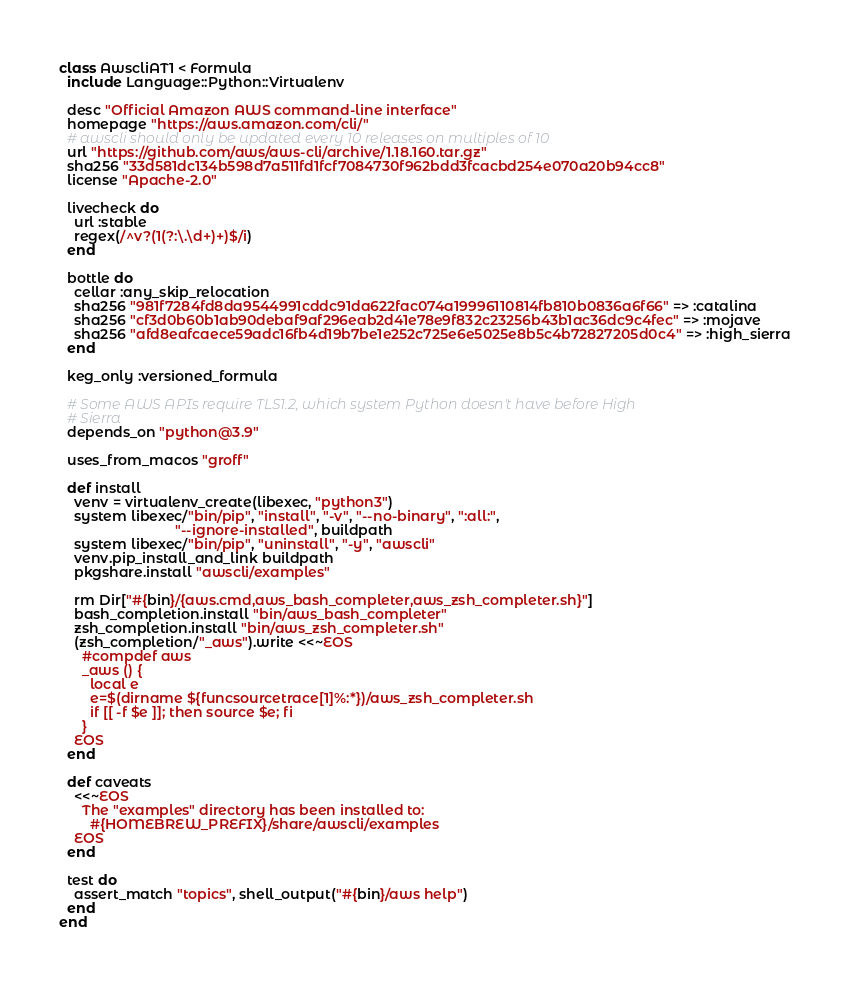<code> <loc_0><loc_0><loc_500><loc_500><_Ruby_>class AwscliAT1 < Formula
  include Language::Python::Virtualenv

  desc "Official Amazon AWS command-line interface"
  homepage "https://aws.amazon.com/cli/"
  # awscli should only be updated every 10 releases on multiples of 10
  url "https://github.com/aws/aws-cli/archive/1.18.160.tar.gz"
  sha256 "33d581dc134b598d7a511fd1fcf7084730f962bdd3fcacbd254e070a20b94cc8"
  license "Apache-2.0"

  livecheck do
    url :stable
    regex(/^v?(1(?:\.\d+)+)$/i)
  end

  bottle do
    cellar :any_skip_relocation
    sha256 "981f7284fd8da9544991cddc91da622fac074a19996110814fb810b0836a6f66" => :catalina
    sha256 "cf3d0b60b1ab90debaf9af296eab2d41e78e9f832c23256b43b1ac36dc9c4fec" => :mojave
    sha256 "afd8eafcaece59adc16fb4d19b7be1e252c725e6e5025e8b5c4b72827205d0c4" => :high_sierra
  end

  keg_only :versioned_formula

  # Some AWS APIs require TLS1.2, which system Python doesn't have before High
  # Sierra
  depends_on "python@3.9"

  uses_from_macos "groff"

  def install
    venv = virtualenv_create(libexec, "python3")
    system libexec/"bin/pip", "install", "-v", "--no-binary", ":all:",
                              "--ignore-installed", buildpath
    system libexec/"bin/pip", "uninstall", "-y", "awscli"
    venv.pip_install_and_link buildpath
    pkgshare.install "awscli/examples"

    rm Dir["#{bin}/{aws.cmd,aws_bash_completer,aws_zsh_completer.sh}"]
    bash_completion.install "bin/aws_bash_completer"
    zsh_completion.install "bin/aws_zsh_completer.sh"
    (zsh_completion/"_aws").write <<~EOS
      #compdef aws
      _aws () {
        local e
        e=$(dirname ${funcsourcetrace[1]%:*})/aws_zsh_completer.sh
        if [[ -f $e ]]; then source $e; fi
      }
    EOS
  end

  def caveats
    <<~EOS
      The "examples" directory has been installed to:
        #{HOMEBREW_PREFIX}/share/awscli/examples
    EOS
  end

  test do
    assert_match "topics", shell_output("#{bin}/aws help")
  end
end
</code> 